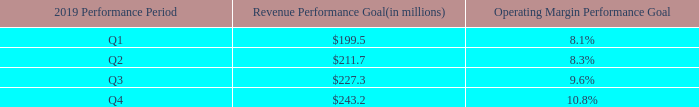1. 2019 Performance Periods and Performance Goals. For the calendar year 2019, there are four quarterly Performance Periods, ending on March 31, June 30, September 30 and December 31, 2019 (each, a “2019 Performance Period”). For each of the four 2019 Performance Periods, there are two equally weighted (50% each) performance goals (each, a “2019 Performance Goal”): Revenue and Operating Margin (each as defined below). The chart below set forth the Revenue and Operating Margin Performance Goals for the four 2019 Performance Periods.
“Revenue” means as to each of the 2019 Performance Periods, the Company’s net revenues generated from third parties, including both services revenues and product revenues as defined in the Company’s Form 10-K filed for the calendar year ended December 31, 2018. Net revenue is defined as gross sales less any pertinent discounts, refunds or other contra-revenue amounts, as presented on the Company’s press releases reporting its quarterly financial results.
“Operating Margin” means as to each of the 2019 Performance Periods, the Company’s non-GAAP operating income divided by its Revenue. Non-GAAP operating income means the Company’s Revenues less cost of revenues and operating expenses, excluding the impact of stock-based compensation expense, amortization of acquisition related intangibles, legal settlement related charges and as adjusted for certain acquisitions, as presented on the Company’s press releases reporting its quarterly financial results
When does each respective quarterly performance period end? March 31, june 30, september 30, december 31. How is net revenue defined? Gross sales less any pertinent discounts, refunds or other contra-revenue amounts, as presented on the company’s press releases reporting its quarterly financial results. What are the respective operating margin performance goal in Q1 and Q2? 8.1%, 8.3%. What is the company's average revenue performance goal in the first two quarters of 2019?
Answer scale should be: million. (199.5 + 211.7)/2 
Answer: 205.6. What is the company's average revenue performance goal in the last two quarters of 2019?
Answer scale should be: million. (227.3 + 243.2)/2 
Answer: 235.25. What is the value of the company's Q1 revenue performance goal as a percentage of its Q2 performance goal?
Answer scale should be: percent. 199.5/211.7 
Answer: 94.24. 